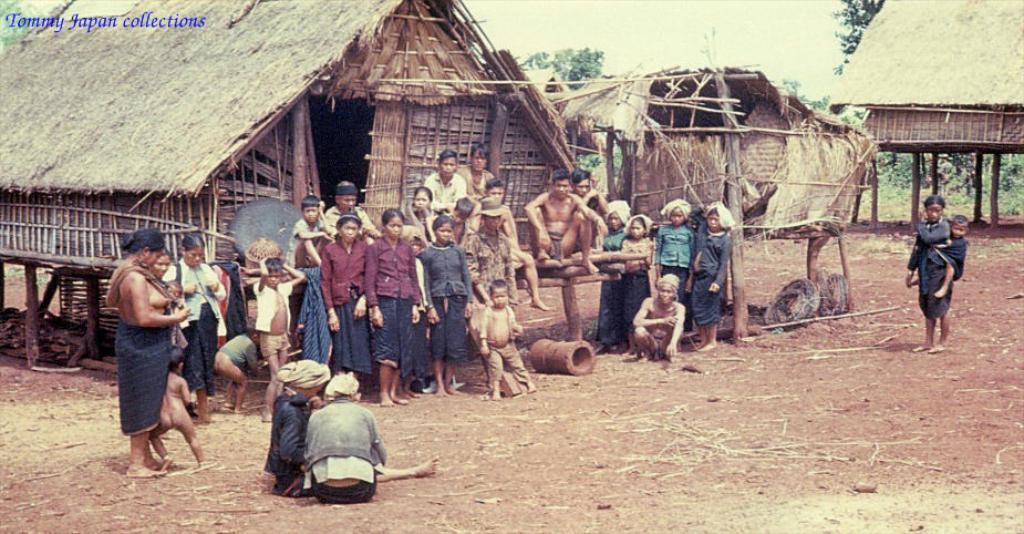What is the main subject of the image? There is a group of people at the center of the image. What can be seen behind the group of people? There are huts behind the group of people. What type of natural environment is visible in the background of the image? There are trees visible in the background of the image. Where is the text located in the image? The text is in the top left hand side of the image. What type of shoes are the people wearing in the image? There is no information about the shoes the people are wearing in the image. 